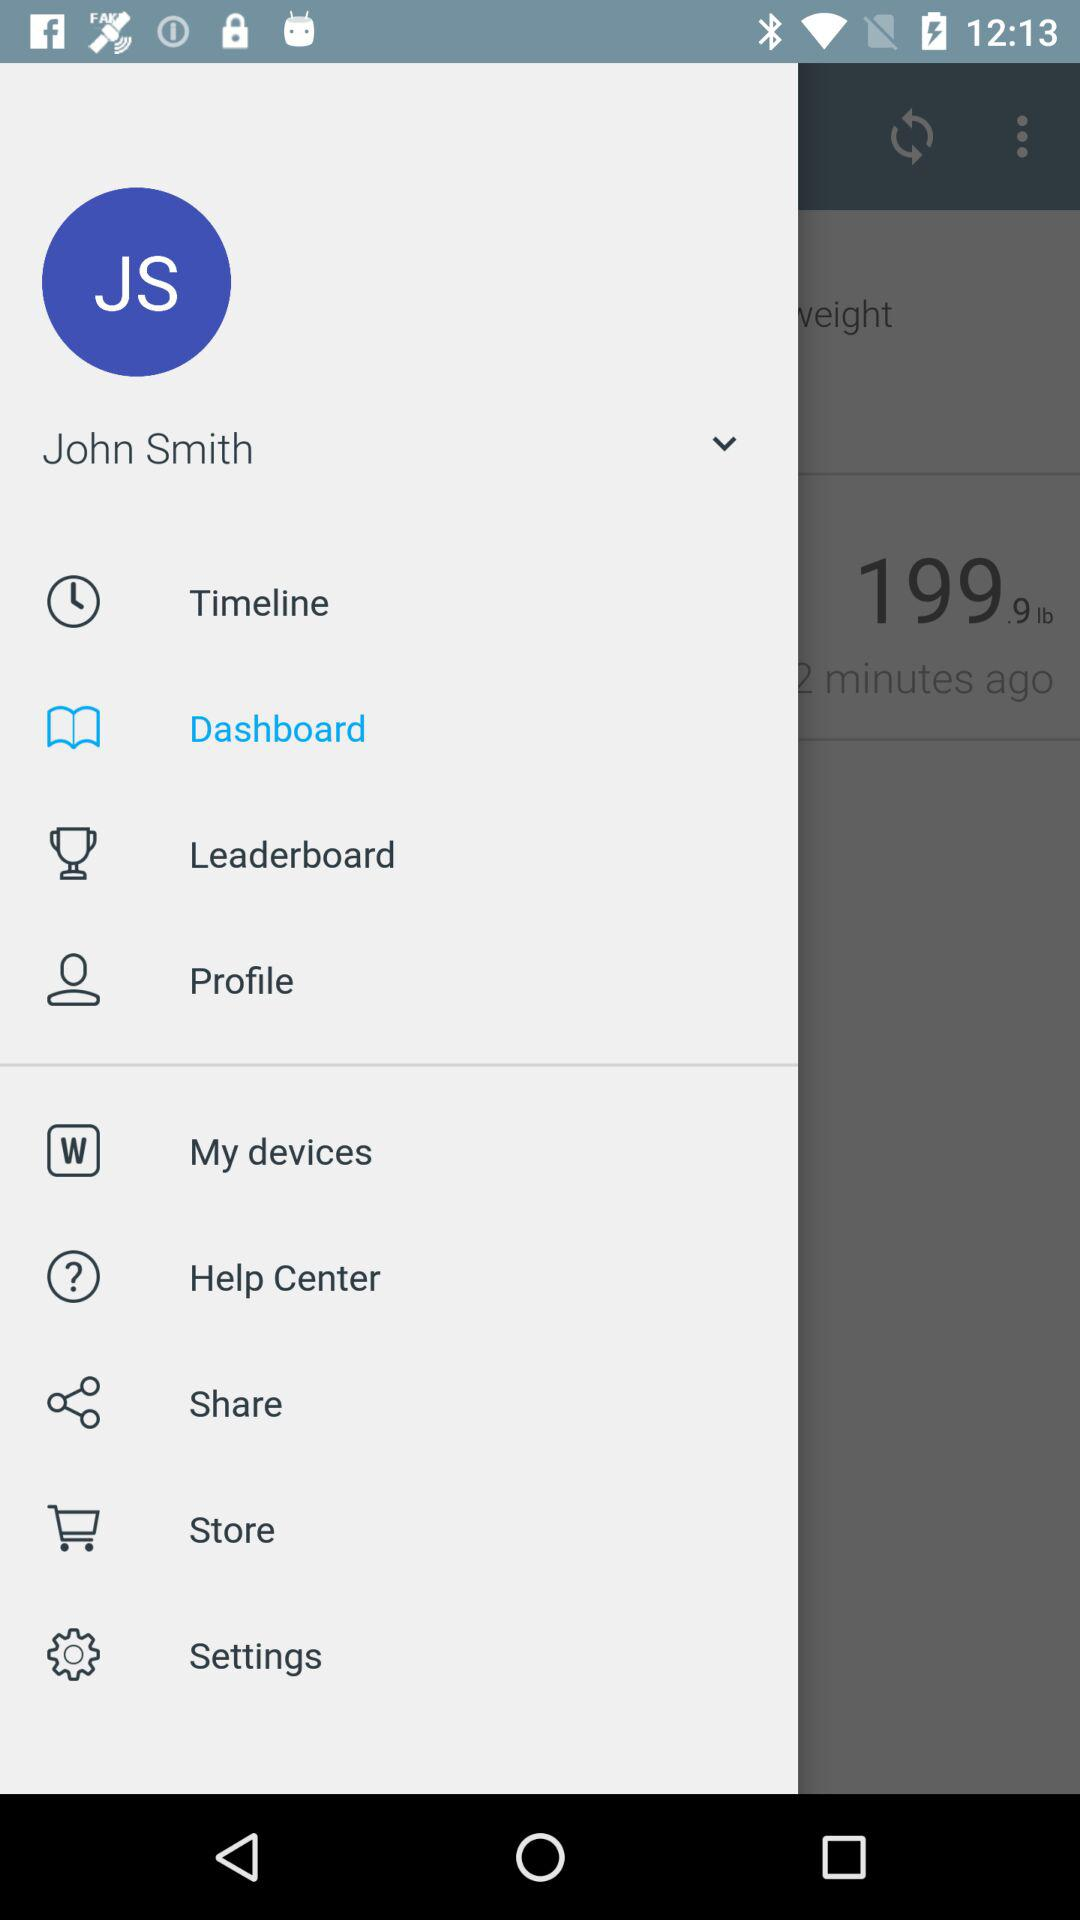Which item is selected? The selected item is "Dashboard". 